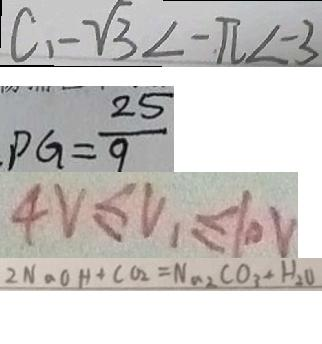<formula> <loc_0><loc_0><loc_500><loc_500>C 、 - \sqrt { 3 } < - \pi < - 3 
 P G = \frac { 2 5 } { 9 } 
 4 V \leq V _ { 1 } \leq 1 0 V 
 2 N a O H + C O _ { 2 } = N a _ { 2 } C O _ { 3 } + H _ { 2 } O</formula> 